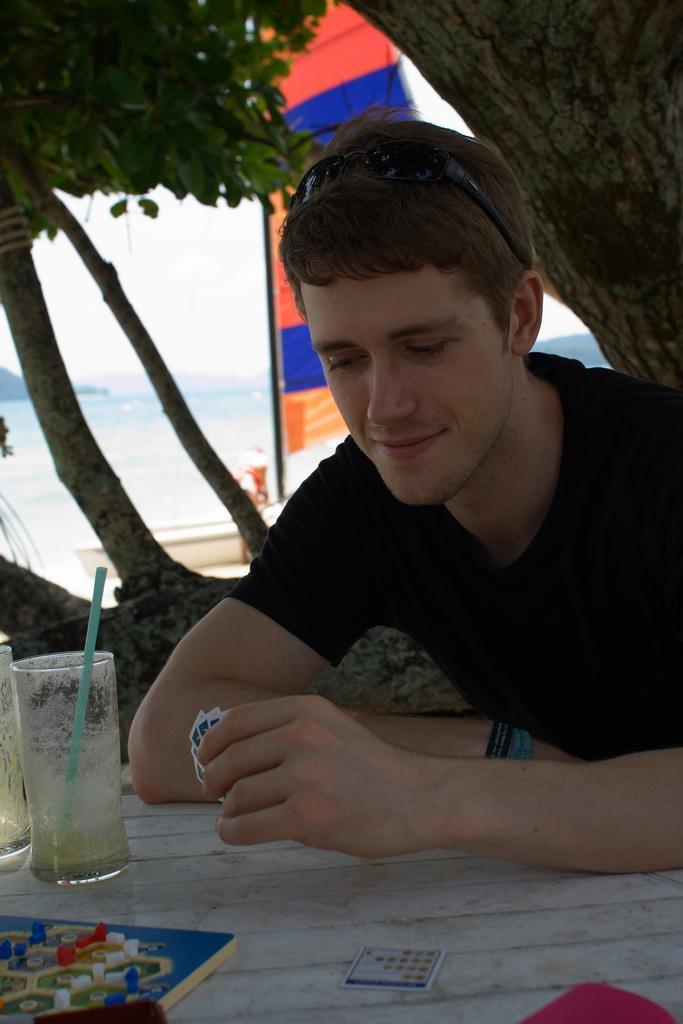In one or two sentences, can you explain what this image depicts? This image consists of a man. There is a table in front of him. There are glasses on the left side. There is a tree at the top. There is water in the middle. 